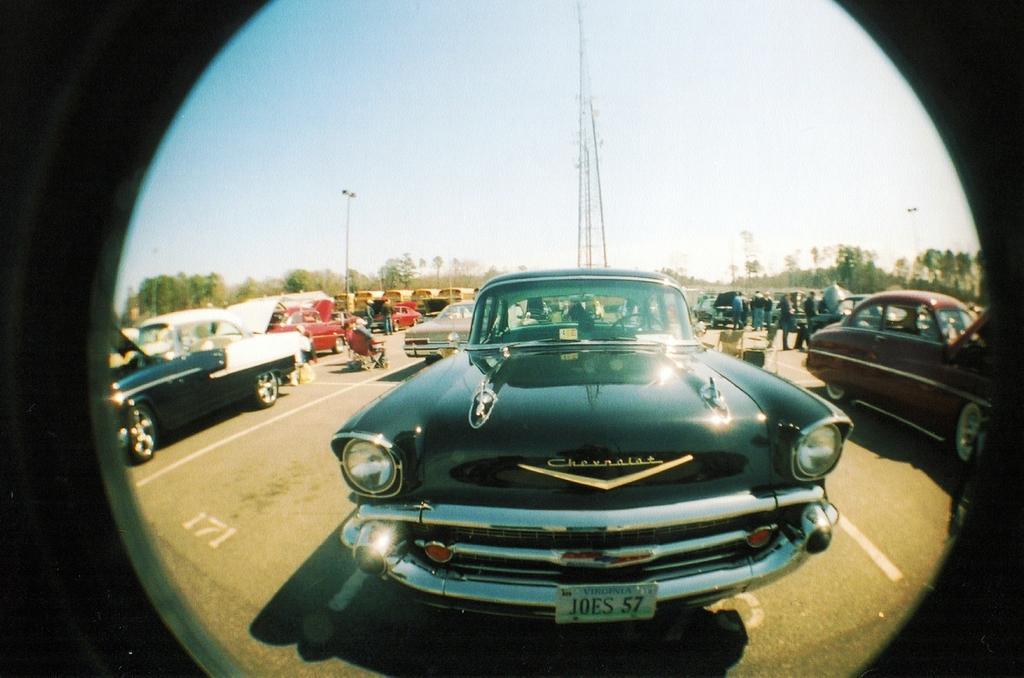Can you describe this image briefly? In this image I see number of cars and I see number of people and I see the road on which there are white lines. In the background I see the trees, 2 poles, a tower and the clear sky and I see that it is dark on the sides. 